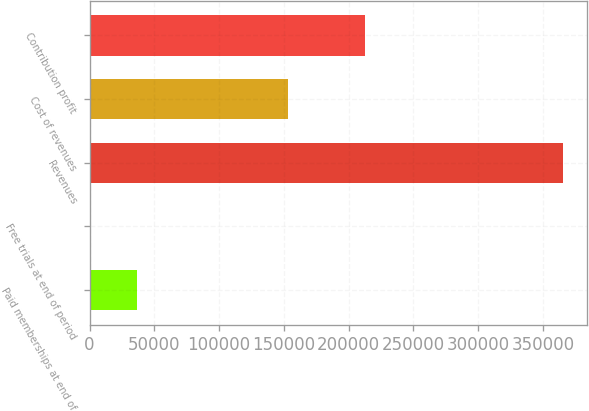Convert chart to OTSL. <chart><loc_0><loc_0><loc_500><loc_500><bar_chart><fcel>Paid memberships at end of<fcel>Free trials at end of period<fcel>Revenues<fcel>Cost of revenues<fcel>Contribution profit<nl><fcel>36581.4<fcel>25<fcel>365589<fcel>153097<fcel>212492<nl></chart> 